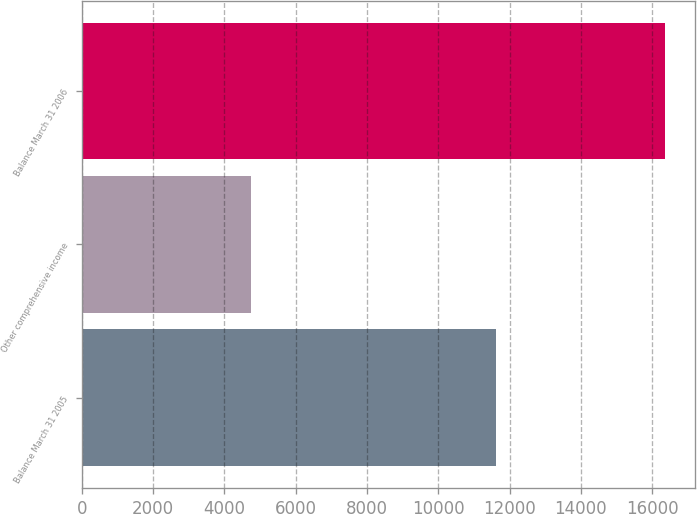Convert chart. <chart><loc_0><loc_0><loc_500><loc_500><bar_chart><fcel>Balance March 31 2005<fcel>Other comprehensive income<fcel>Balance March 31 2006<nl><fcel>11618<fcel>4751<fcel>16369<nl></chart> 